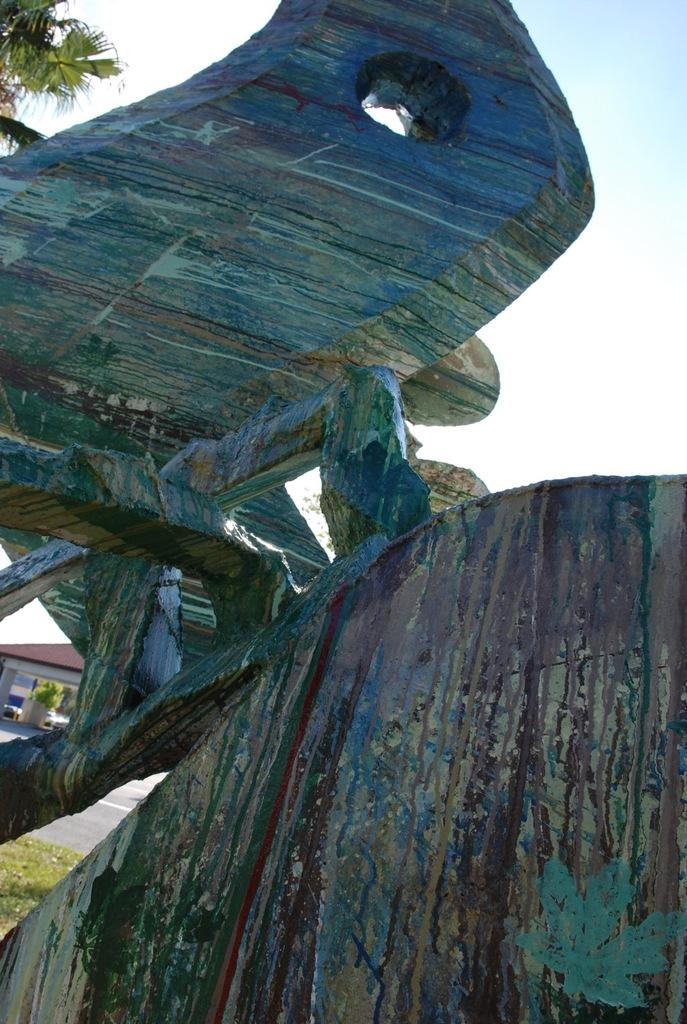What is the main subject in the center of the image? There is a sculpture in the center of the image. What can be seen in the background of the image? There are houses and trees in the background of the image. Can you hear the sound of thunder in the image? There is no sound present in the image, so it is not possible to hear thunder or any other sounds. 